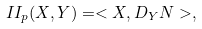Convert formula to latex. <formula><loc_0><loc_0><loc_500><loc_500>I I _ { p } ( X , Y ) = < X , D _ { Y } N > ,</formula> 